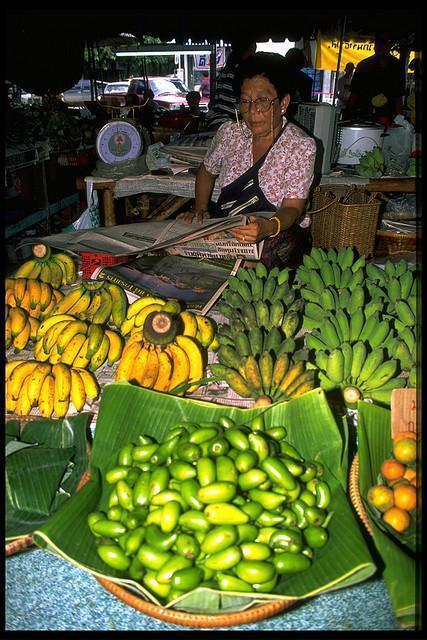What purpose does the weight in the back serve?
Choose the correct response, then elucidate: 'Answer: answer
Rationale: rationale.'
Options: Paper weight, weigh money, balance table, measure price. Answer: measure price.
Rationale: Fruits and vegetables are placed on the weight and then you pay by the weight. 